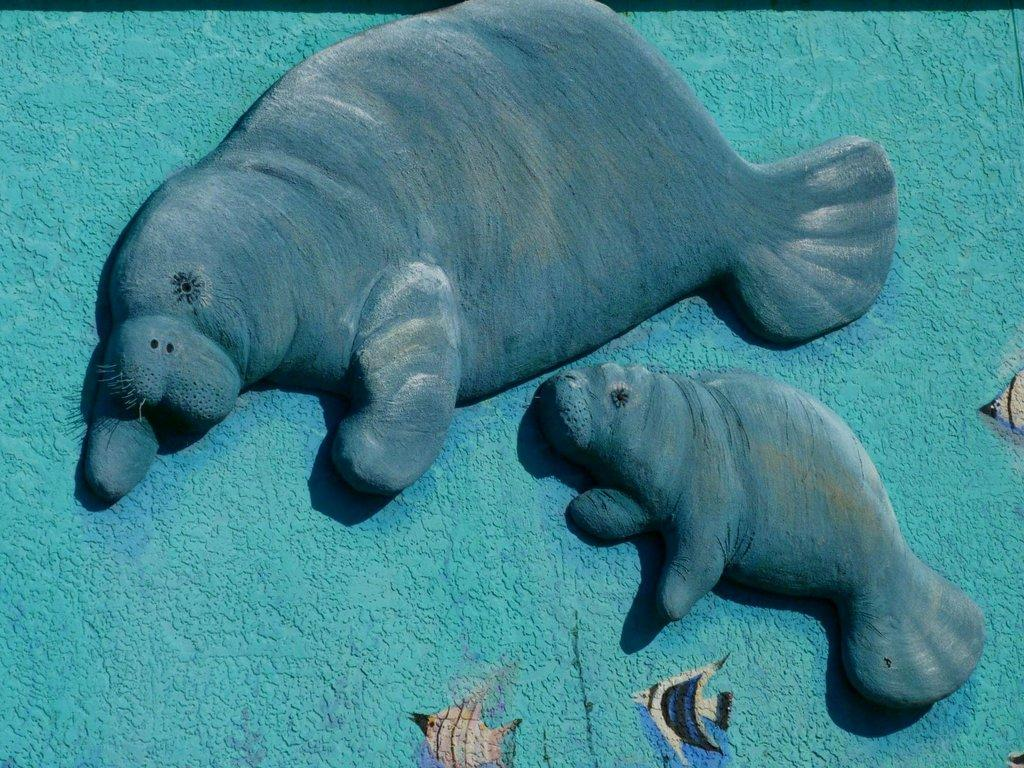What type of artwork can be seen on the wall in the image? There are sculptures on the wall in the image. Can you describe the sculptures in more detail? Unfortunately, the image does not provide enough detail to describe the sculptures further. What is the primary color of the wall in the image? The image does not provide enough detail to determine the primary color of the wall. Is there snow on the ground in the image? There is no information about the ground or any snow in the image, as it only shows sculptures on a wall. 